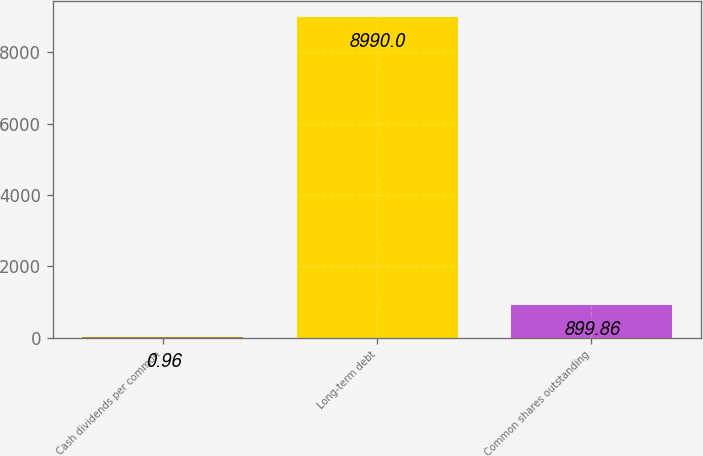Convert chart to OTSL. <chart><loc_0><loc_0><loc_500><loc_500><bar_chart><fcel>Cash dividends per common<fcel>Long-term debt<fcel>Common shares outstanding<nl><fcel>0.96<fcel>8990<fcel>899.86<nl></chart> 